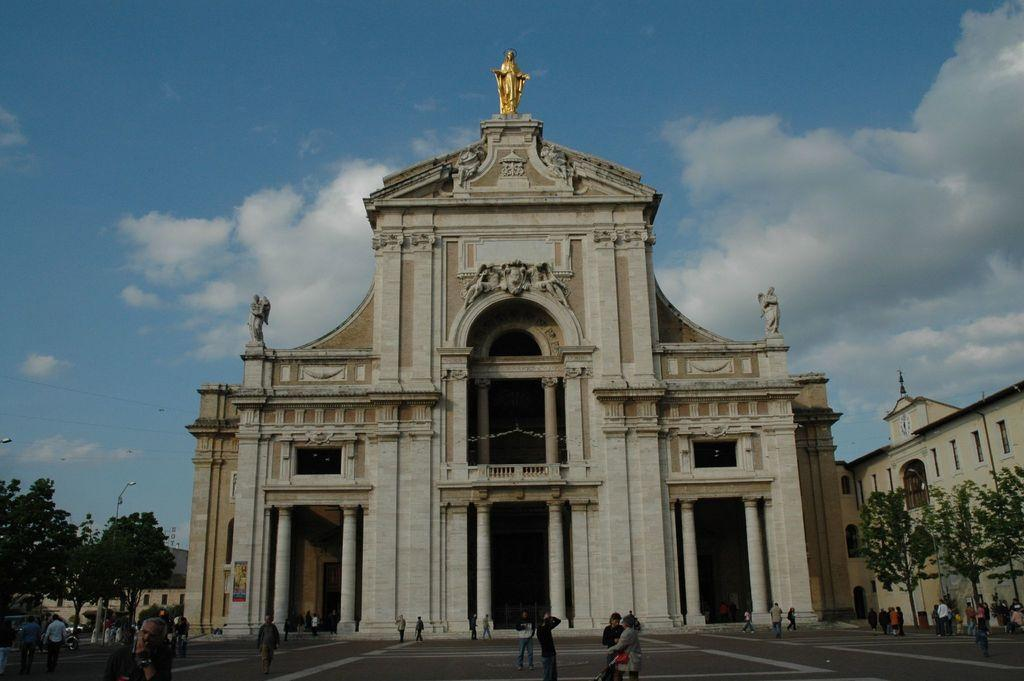What type of structures can be seen in the image? There are buildings in the image. What are the people in the image doing? There are people walking in the image. What type of vegetation is visible in the image? There are trees visible in the image. What else can be seen moving in the image besides people? There are vehicles in the image. What type of egg is being used to hold the fork in the image? There is no egg or fork present in the image. What type of bean is growing on the trees in the image? There are no beans growing on the trees in the image; there are trees visible, but no specific plants or crops are mentioned. 